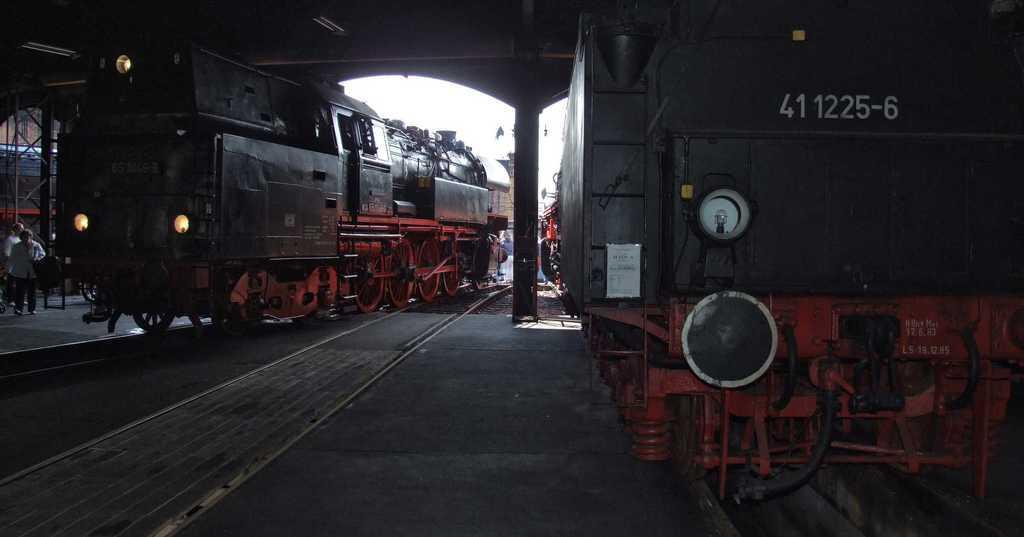Could you give a brief overview of what you see in this image? In this image I can see the ground, few railway tracks and two trains which are red and black in color on the tracks. I can see few persons standing, few metal pillars, the ceiling and the sky in the background. 